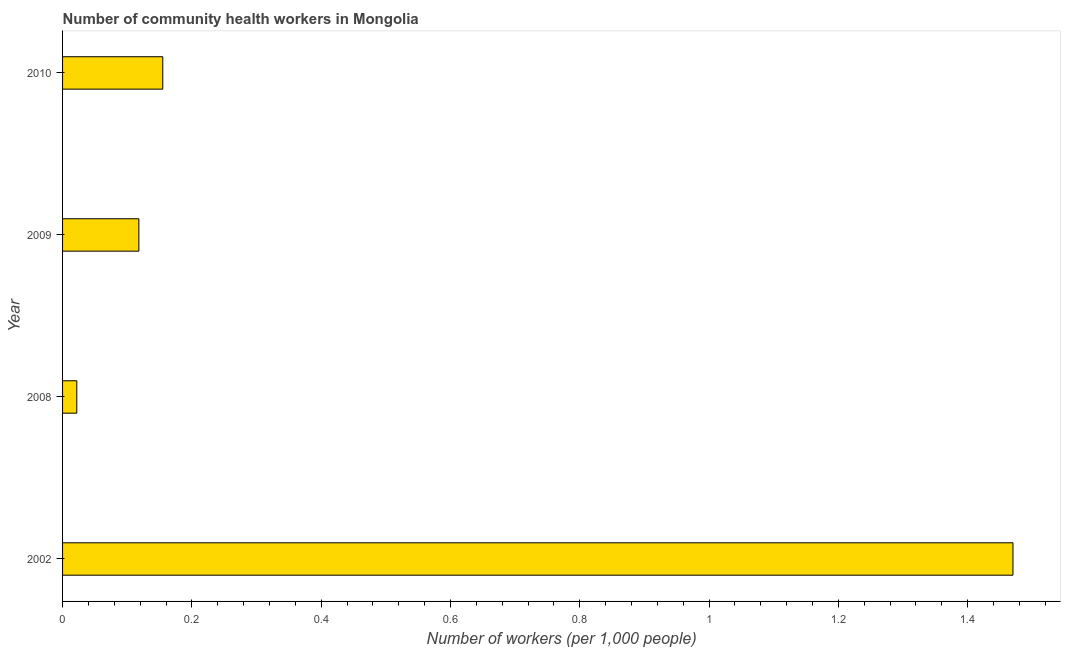Does the graph contain any zero values?
Ensure brevity in your answer.  No. What is the title of the graph?
Make the answer very short. Number of community health workers in Mongolia. What is the label or title of the X-axis?
Give a very brief answer. Number of workers (per 1,0 people). What is the label or title of the Y-axis?
Give a very brief answer. Year. What is the number of community health workers in 2008?
Keep it short and to the point. 0.02. Across all years, what is the maximum number of community health workers?
Keep it short and to the point. 1.47. Across all years, what is the minimum number of community health workers?
Keep it short and to the point. 0.02. In which year was the number of community health workers maximum?
Offer a very short reply. 2002. What is the sum of the number of community health workers?
Offer a terse response. 1.76. What is the difference between the number of community health workers in 2002 and 2008?
Your answer should be compact. 1.45. What is the average number of community health workers per year?
Keep it short and to the point. 0.44. What is the median number of community health workers?
Give a very brief answer. 0.14. Do a majority of the years between 2002 and 2010 (inclusive) have number of community health workers greater than 0.08 ?
Your response must be concise. Yes. What is the ratio of the number of community health workers in 2009 to that in 2010?
Provide a succinct answer. 0.76. Is the number of community health workers in 2002 less than that in 2008?
Give a very brief answer. No. What is the difference between the highest and the second highest number of community health workers?
Offer a very short reply. 1.31. Is the sum of the number of community health workers in 2008 and 2010 greater than the maximum number of community health workers across all years?
Offer a very short reply. No. What is the difference between the highest and the lowest number of community health workers?
Give a very brief answer. 1.45. In how many years, is the number of community health workers greater than the average number of community health workers taken over all years?
Provide a short and direct response. 1. How many years are there in the graph?
Ensure brevity in your answer.  4. Are the values on the major ticks of X-axis written in scientific E-notation?
Give a very brief answer. No. What is the Number of workers (per 1,000 people) of 2002?
Provide a succinct answer. 1.47. What is the Number of workers (per 1,000 people) of 2008?
Make the answer very short. 0.02. What is the Number of workers (per 1,000 people) in 2009?
Offer a very short reply. 0.12. What is the Number of workers (per 1,000 people) in 2010?
Give a very brief answer. 0.15. What is the difference between the Number of workers (per 1,000 people) in 2002 and 2008?
Keep it short and to the point. 1.45. What is the difference between the Number of workers (per 1,000 people) in 2002 and 2009?
Give a very brief answer. 1.35. What is the difference between the Number of workers (per 1,000 people) in 2002 and 2010?
Give a very brief answer. 1.31. What is the difference between the Number of workers (per 1,000 people) in 2008 and 2009?
Make the answer very short. -0.1. What is the difference between the Number of workers (per 1,000 people) in 2008 and 2010?
Ensure brevity in your answer.  -0.13. What is the difference between the Number of workers (per 1,000 people) in 2009 and 2010?
Ensure brevity in your answer.  -0.04. What is the ratio of the Number of workers (per 1,000 people) in 2002 to that in 2008?
Provide a short and direct response. 66.82. What is the ratio of the Number of workers (per 1,000 people) in 2002 to that in 2009?
Your answer should be very brief. 12.46. What is the ratio of the Number of workers (per 1,000 people) in 2002 to that in 2010?
Offer a very short reply. 9.48. What is the ratio of the Number of workers (per 1,000 people) in 2008 to that in 2009?
Offer a terse response. 0.19. What is the ratio of the Number of workers (per 1,000 people) in 2008 to that in 2010?
Your answer should be very brief. 0.14. What is the ratio of the Number of workers (per 1,000 people) in 2009 to that in 2010?
Your answer should be compact. 0.76. 